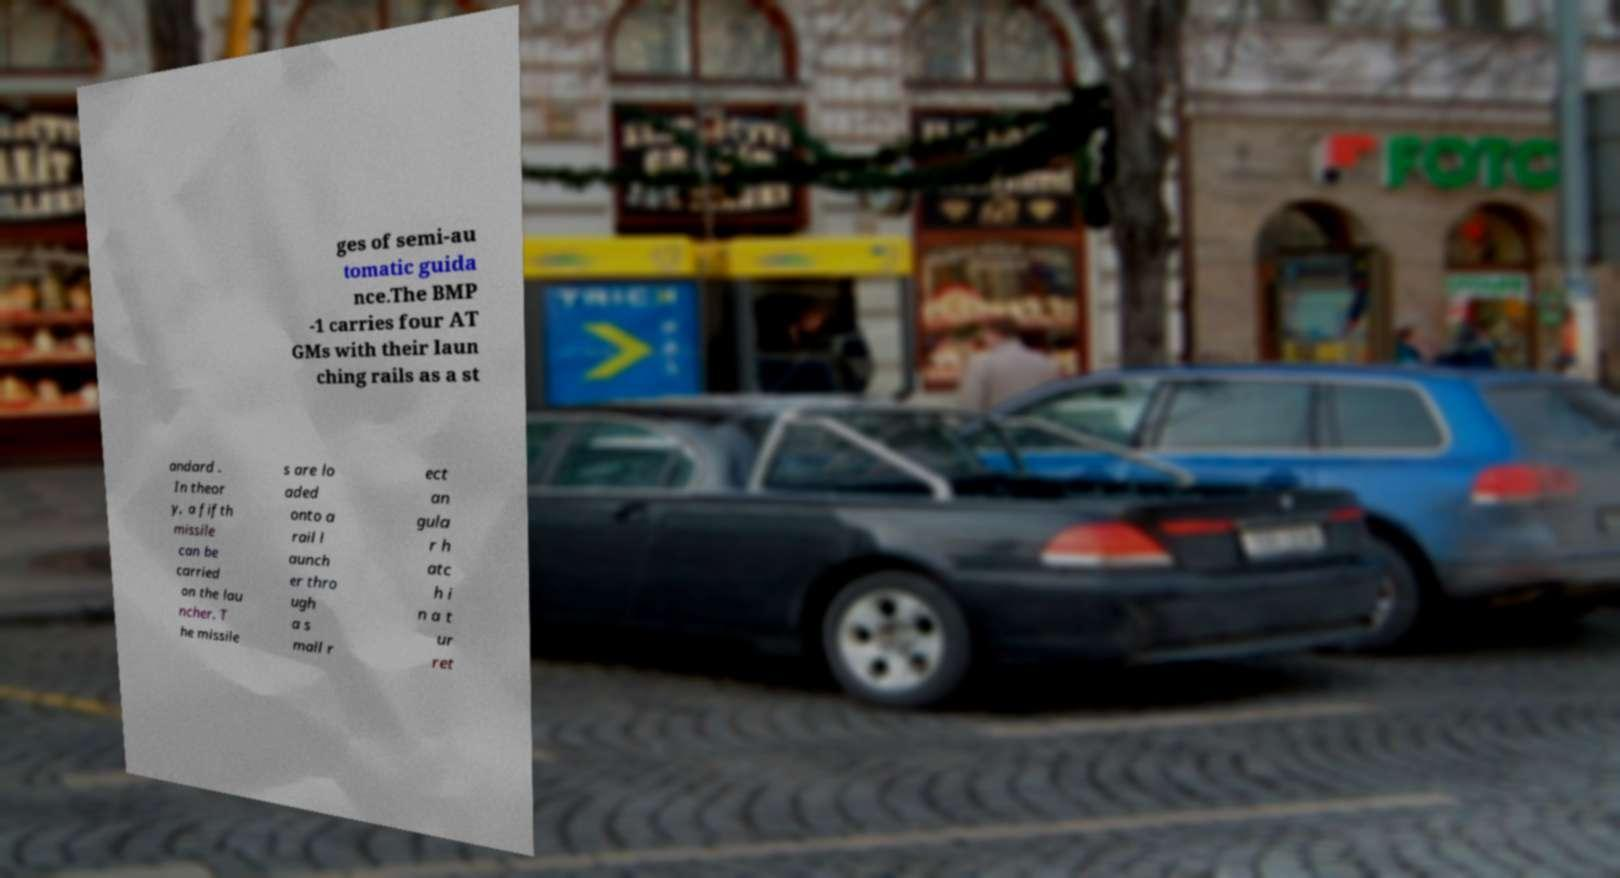For documentation purposes, I need the text within this image transcribed. Could you provide that? ges of semi-au tomatic guida nce.The BMP -1 carries four AT GMs with their laun ching rails as a st andard . In theor y, a fifth missile can be carried on the lau ncher. T he missile s are lo aded onto a rail l aunch er thro ugh a s mall r ect an gula r h atc h i n a t ur ret 